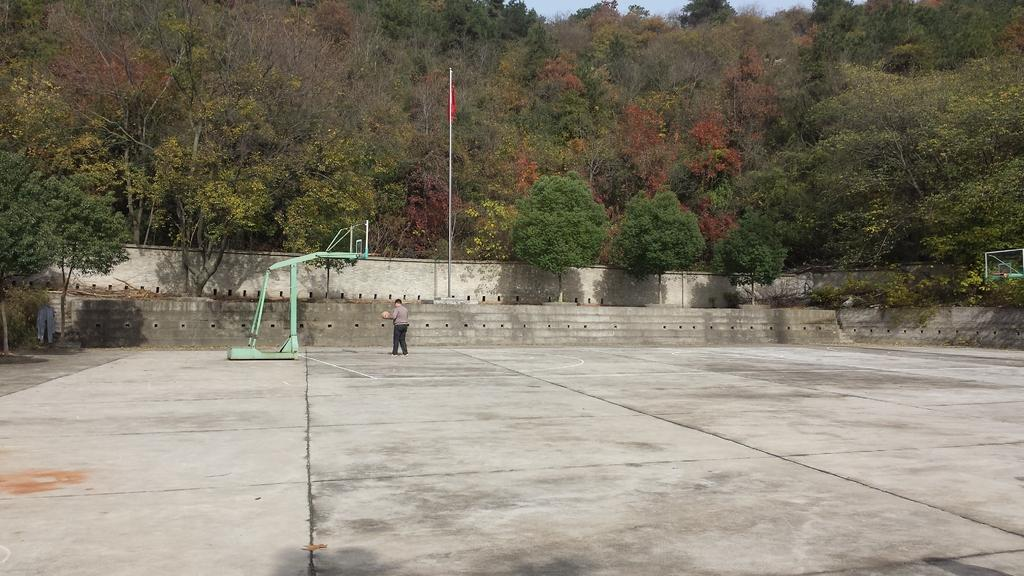What is the main subject of the image? There is a person in the image. What is the person holding in their hands? The person is holding a ball in their hands. What objects are in front of the person? There are metal rods in front of the person. What can be seen in the background of the image? There are trees, a flag, and a pole in the background of the image. What type of seat can be seen in the image? There is no seat present in the image. What invention is the person demonstrating in the image? The image does not depict any specific invention; it simply shows a person holding a ball. 